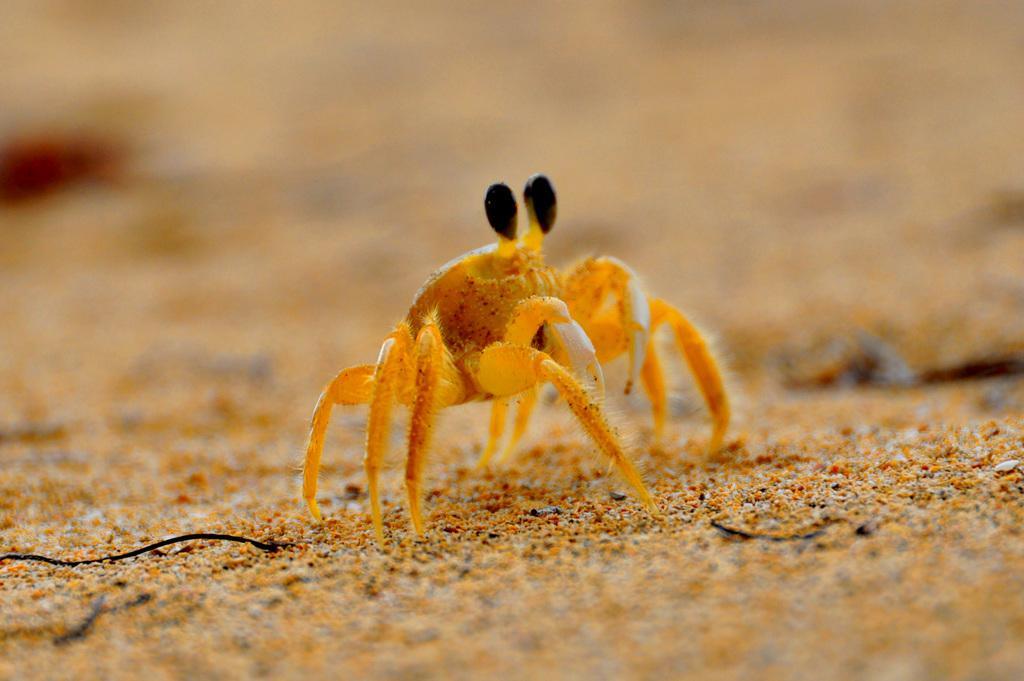In one or two sentences, can you explain what this image depicts? Here we can see an insect on the ground. In the background the image is blur. 